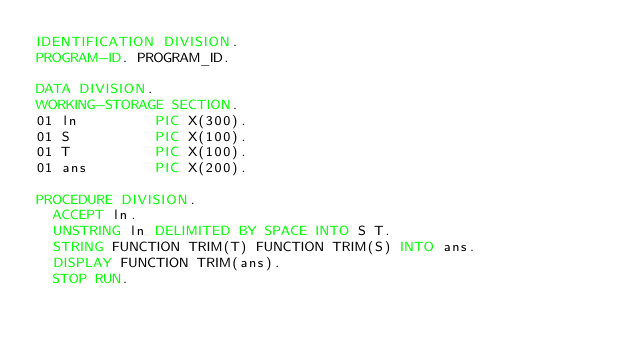<code> <loc_0><loc_0><loc_500><loc_500><_COBOL_>IDENTIFICATION DIVISION.
PROGRAM-ID. PROGRAM_ID.

DATA DIVISION.
WORKING-STORAGE SECTION.
01 ln         PIC X(300).
01 S          PIC X(100).
01 T          PIC X(100).
01 ans        PIC X(200).

PROCEDURE DIVISION.
  ACCEPT ln.
  UNSTRING ln DELIMITED BY SPACE INTO S T.
  STRING FUNCTION TRIM(T) FUNCTION TRIM(S) INTO ans.
  DISPLAY FUNCTION TRIM(ans).
  STOP RUN.
</code> 